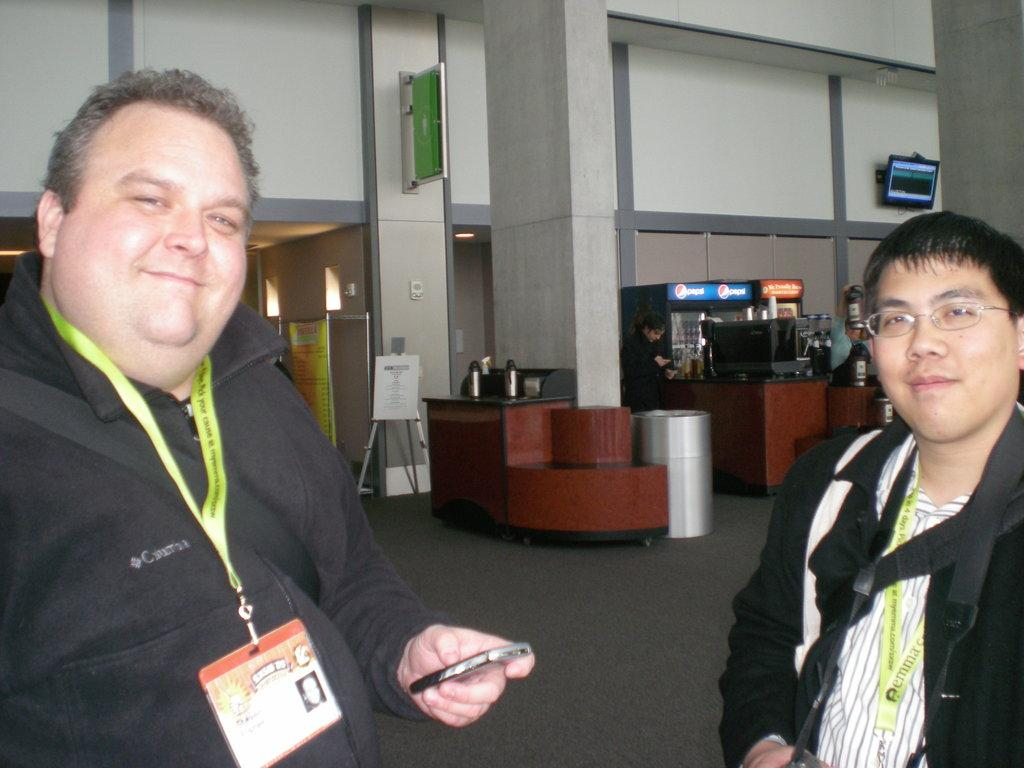How many people are in the image? There are two people standing in the image. What are the people holding? The people are holding something, but the specific item is not mentioned in the facts. What can be seen in the background of the image? There are boards, a stand, fridges, objects on a table, and a screen on the wall visible in the background. What type of sea creatures can be seen swimming on the screen in the image? There is no mention of sea creatures or a screen displaying them in the provided facts. 